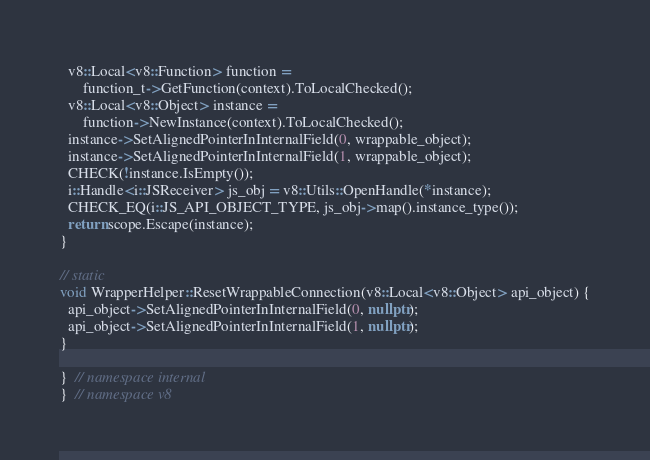<code> <loc_0><loc_0><loc_500><loc_500><_C++_>  v8::Local<v8::Function> function =
      function_t->GetFunction(context).ToLocalChecked();
  v8::Local<v8::Object> instance =
      function->NewInstance(context).ToLocalChecked();
  instance->SetAlignedPointerInInternalField(0, wrappable_object);
  instance->SetAlignedPointerInInternalField(1, wrappable_object);
  CHECK(!instance.IsEmpty());
  i::Handle<i::JSReceiver> js_obj = v8::Utils::OpenHandle(*instance);
  CHECK_EQ(i::JS_API_OBJECT_TYPE, js_obj->map().instance_type());
  return scope.Escape(instance);
}

// static
void WrapperHelper::ResetWrappableConnection(v8::Local<v8::Object> api_object) {
  api_object->SetAlignedPointerInInternalField(0, nullptr);
  api_object->SetAlignedPointerInInternalField(1, nullptr);
}

}  // namespace internal
}  // namespace v8
</code> 